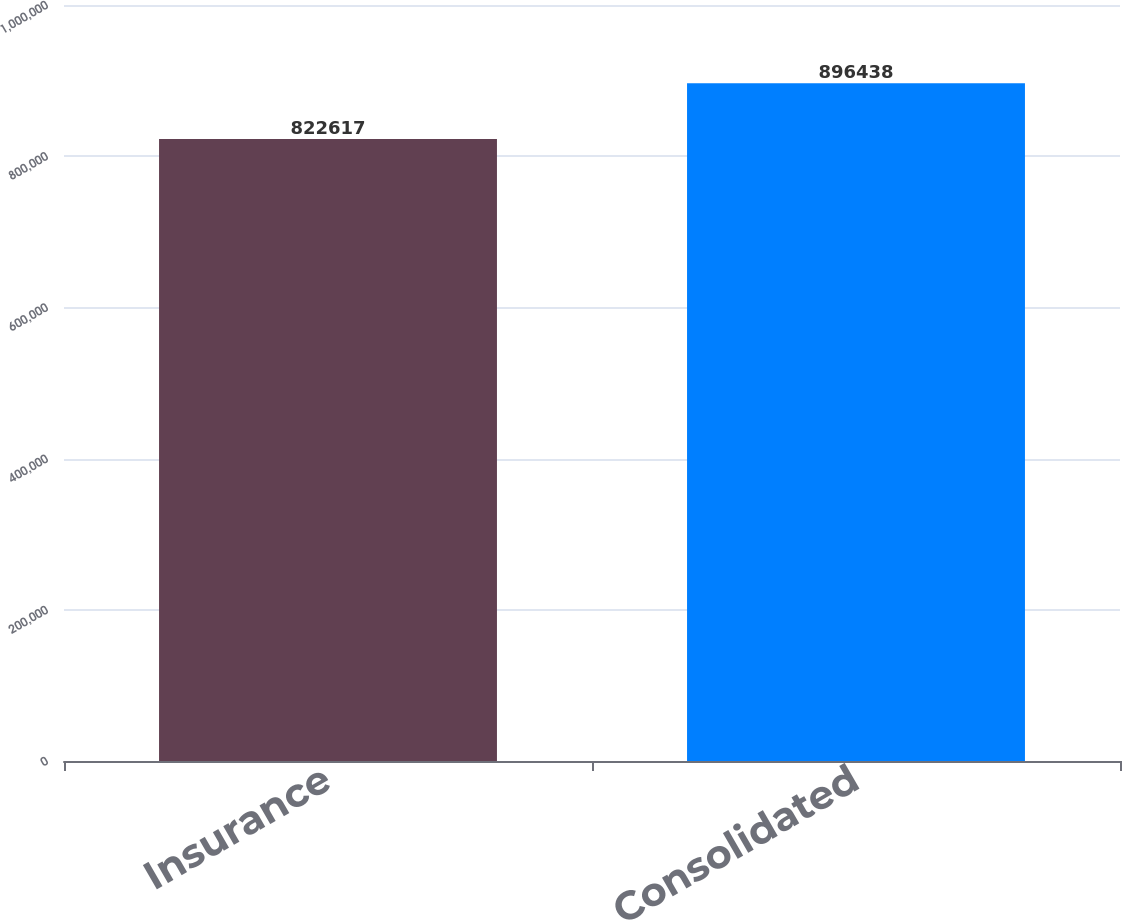<chart> <loc_0><loc_0><loc_500><loc_500><bar_chart><fcel>Insurance<fcel>Consolidated<nl><fcel>822617<fcel>896438<nl></chart> 